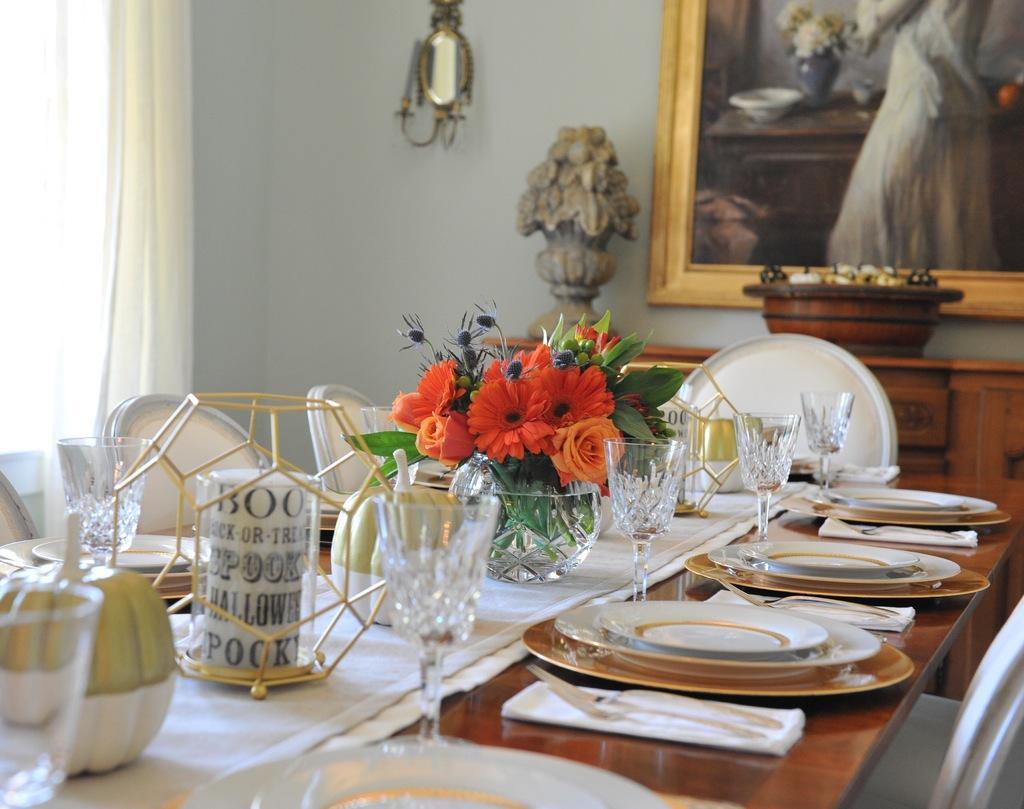Please provide a concise description of this image. In this image I can see a table with a couple of plates, glasses and other objects on it. I can also see there is a curtain and a photo on a wall. 